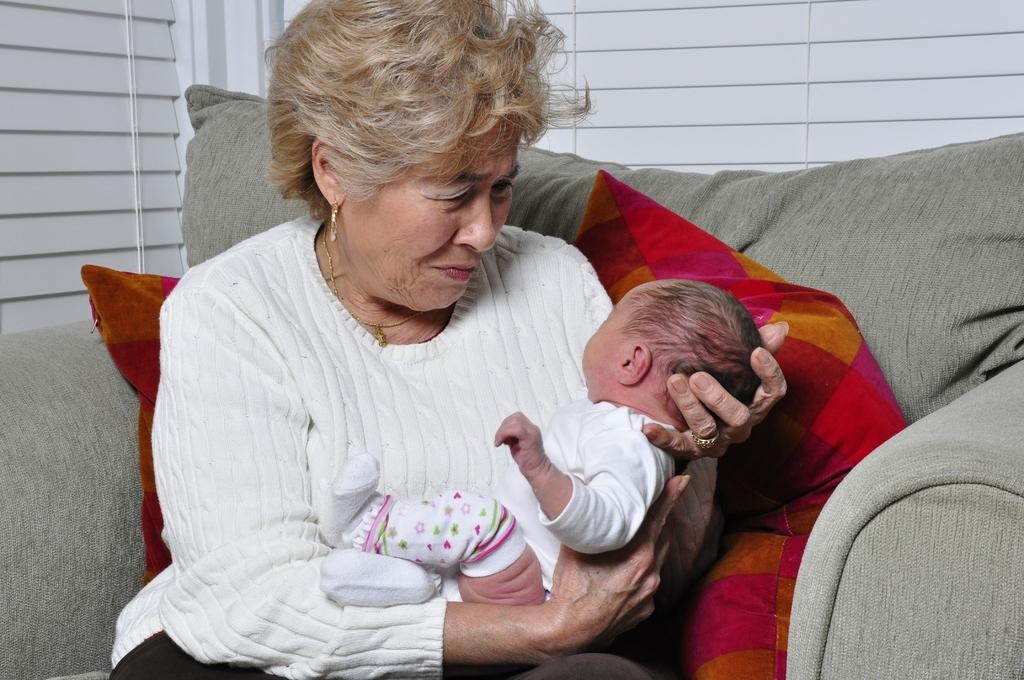Who is the main subject in the image? There is a woman in the image. What is the woman doing in the image? The woman is holding a baby. What is the woman's position in the image? The woman is sitting on a chair. What can be seen in the background of the image? There is a window and window mats visible in the background of the image. What might be used for comfort or support in the image? Pillows are visible in the image. What type of shoe is the woman wearing in the image? There is no shoe visible in the image; the woman is sitting on a chair and holding a baby. 